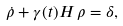<formula> <loc_0><loc_0><loc_500><loc_500>\dot { \rho } + \gamma ( t ) H \, \rho = \delta ,</formula> 